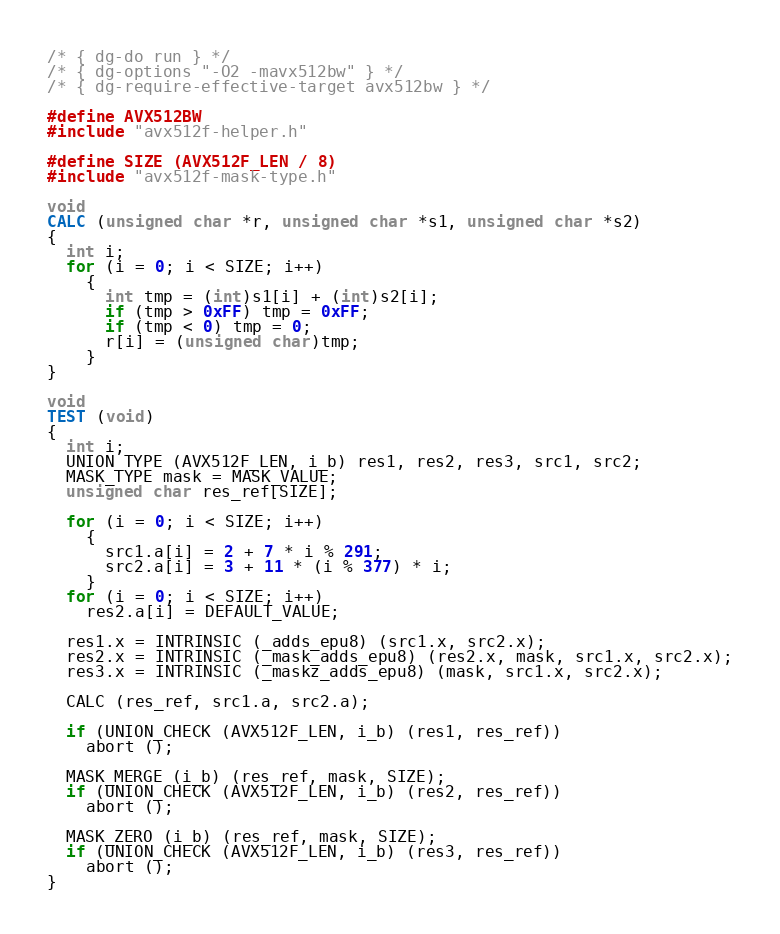<code> <loc_0><loc_0><loc_500><loc_500><_C_>/* { dg-do run } */
/* { dg-options "-O2 -mavx512bw" } */
/* { dg-require-effective-target avx512bw } */

#define AVX512BW
#include "avx512f-helper.h"

#define SIZE (AVX512F_LEN / 8)
#include "avx512f-mask-type.h"

void
CALC (unsigned char *r, unsigned char *s1, unsigned char *s2)
{
  int i;
  for (i = 0; i < SIZE; i++)
    {
      int tmp = (int)s1[i] + (int)s2[i];
      if (tmp > 0xFF) tmp = 0xFF;
      if (tmp < 0) tmp = 0;
      r[i] = (unsigned char)tmp;
    }
}

void
TEST (void)
{
  int i;
  UNION_TYPE (AVX512F_LEN, i_b) res1, res2, res3, src1, src2;
  MASK_TYPE mask = MASK_VALUE;
  unsigned char res_ref[SIZE];

  for (i = 0; i < SIZE; i++)
    {
      src1.a[i] = 2 + 7 * i % 291;
      src2.a[i] = 3 + 11 * (i % 377) * i;
    }
  for (i = 0; i < SIZE; i++)
    res2.a[i] = DEFAULT_VALUE;

  res1.x = INTRINSIC (_adds_epu8) (src1.x, src2.x);
  res2.x = INTRINSIC (_mask_adds_epu8) (res2.x, mask, src1.x, src2.x);
  res3.x = INTRINSIC (_maskz_adds_epu8) (mask, src1.x, src2.x);

  CALC (res_ref, src1.a, src2.a);

  if (UNION_CHECK (AVX512F_LEN, i_b) (res1, res_ref))
    abort ();

  MASK_MERGE (i_b) (res_ref, mask, SIZE);
  if (UNION_CHECK (AVX512F_LEN, i_b) (res2, res_ref))
    abort ();

  MASK_ZERO (i_b) (res_ref, mask, SIZE);
  if (UNION_CHECK (AVX512F_LEN, i_b) (res3, res_ref))
    abort ();
}
</code> 